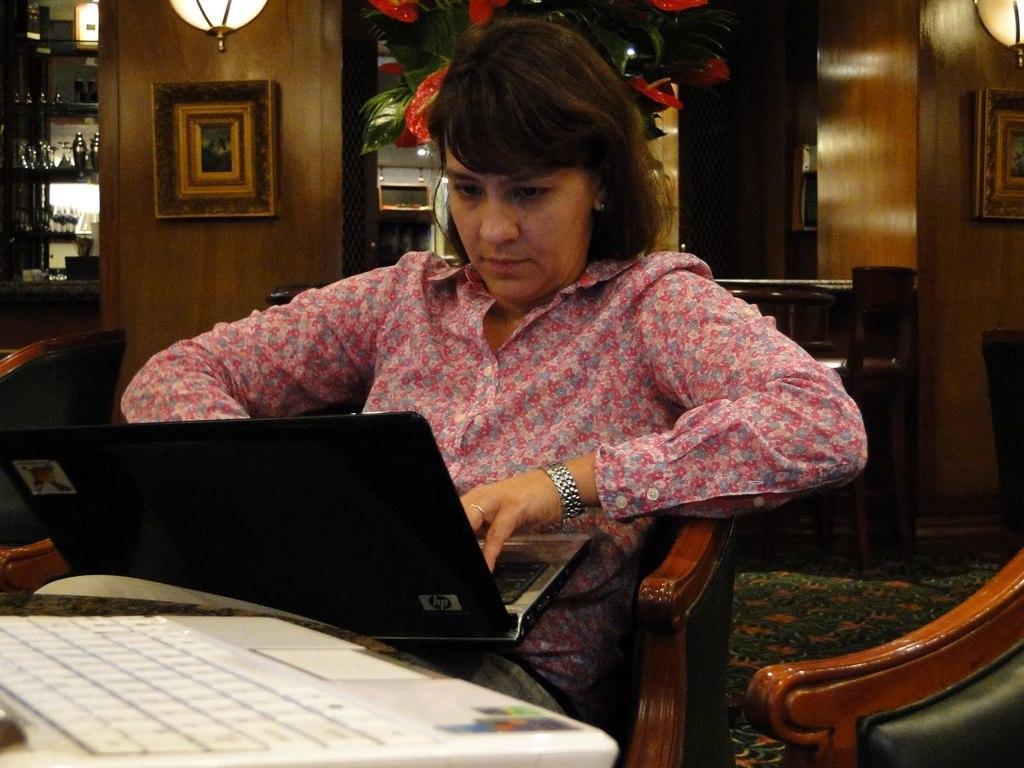Describe this image in one or two sentences. In this picture the woman is sitting on a chair. The woman is holding a hp laptop. To the right hand she is having a watch. Background of the women there is a wooden wall, on the wall there is a photo frame and a light and this is a shelf in the shelf there are the glasses. 